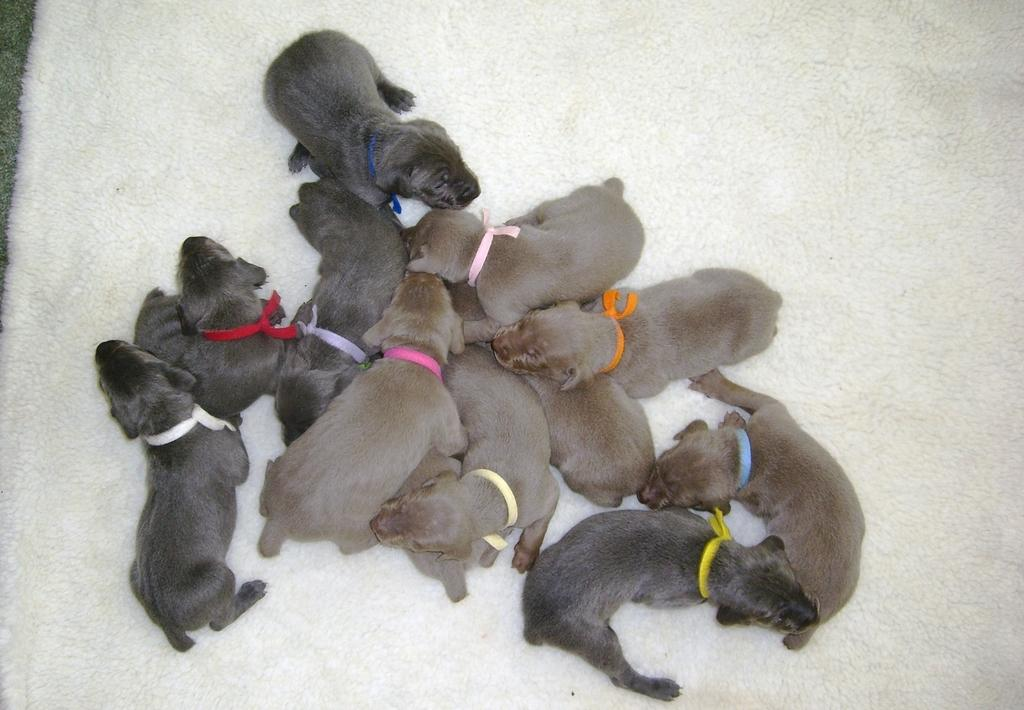What is the main subject in the foreground of the image? There are puppies in the foreground of the image. What is the surface the puppies are on? The puppies are on a white surface. Can you describe the background of the image? There is grass visible on the left top of the image. How many icicles can be seen hanging from the puppies in the image? There are no icicles present in the image; it features puppies on a white surface with grass visible in the background. What type of creature is interacting with the puppies in the image? There is no other creature interacting with the puppies in the image; it only features the puppies on a white surface with grass visible in the background. 